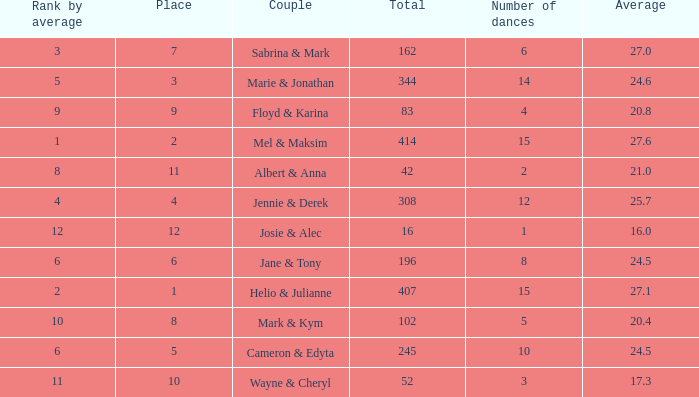What is the average when the rank by average is more than 12? None. 